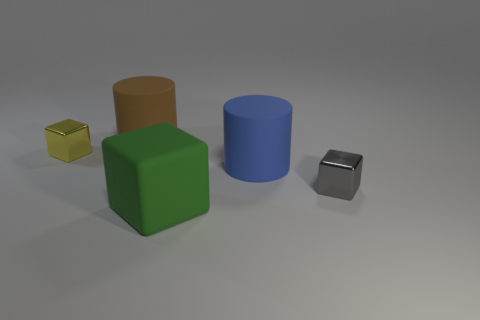There is another rubber thing that is the same shape as the brown object; what is its size?
Offer a very short reply. Large. How many other objects are there of the same material as the tiny gray block?
Make the answer very short. 1. What is the material of the brown object?
Your answer should be very brief. Rubber. Is the number of rubber blocks to the left of the gray metal block greater than the number of big yellow metallic spheres?
Your response must be concise. Yes. Does the thing that is behind the yellow metallic block have the same size as the green block?
Your answer should be very brief. Yes. Are there any brown cylinders of the same size as the blue matte object?
Your answer should be compact. Yes. There is a metallic thing that is behind the blue cylinder; what color is it?
Provide a succinct answer. Yellow. What is the shape of the rubber thing that is in front of the yellow shiny cube and behind the large green thing?
Keep it short and to the point. Cylinder. What number of other large objects are the same shape as the blue object?
Offer a very short reply. 1. How many brown rubber cylinders are there?
Offer a very short reply. 1. 